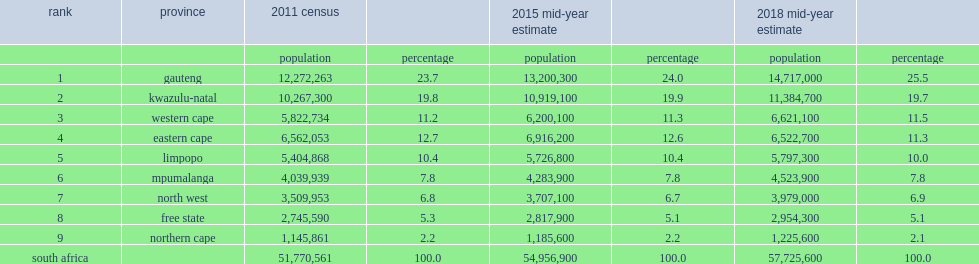Which province is the third most populous province, with an estimated 6.6 million inhabitants in 2018? Western cape. 